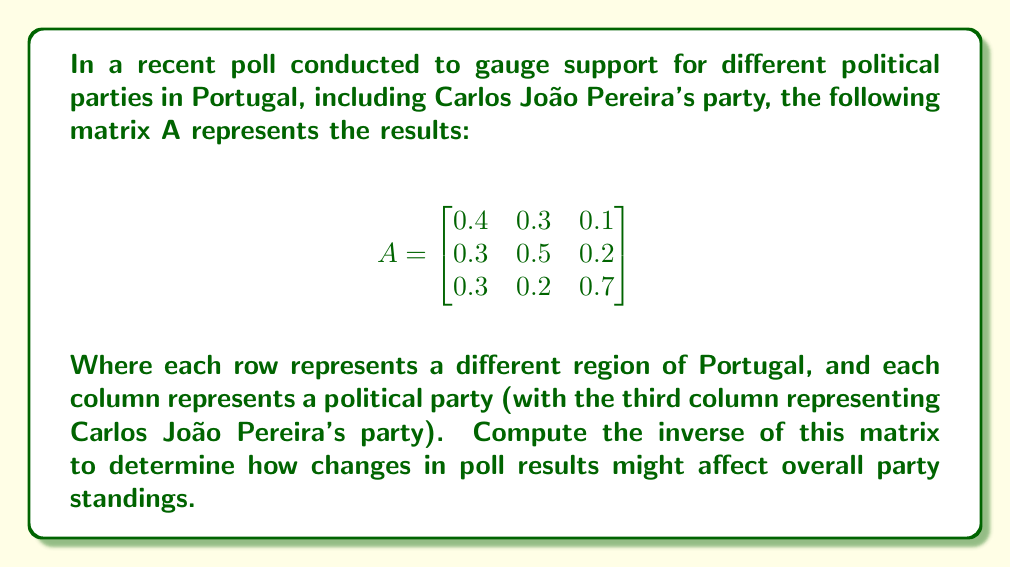Could you help me with this problem? To find the inverse of matrix A, we'll follow these steps:

1) First, we need to calculate the determinant of A:

   $det(A) = 0.4(0.5 \cdot 0.7 - 0.2 \cdot 0.2) - 0.3(0.3 \cdot 0.7 - 0.2 \cdot 0.3) + 0.1(0.3 \cdot 0.2 - 0.5 \cdot 0.3)$
   $= 0.4(0.35 - 0.04) - 0.3(0.21 - 0.06) + 0.1(0.06 - 0.15)$
   $= 0.4(0.31) - 0.3(0.15) + 0.1(-0.09)$
   $= 0.124 - 0.045 - 0.009 = 0.07$

2) Now we calculate the adjugate matrix:

   $adj(A) = \begin{bmatrix}
   (0.5 \cdot 0.7 - 0.2 \cdot 0.2) & -(0.3 \cdot 0.7 - 0.1 \cdot 0.3) & (0.3 \cdot 0.2 - 0.1 \cdot 0.5) \\
   -(0.3 \cdot 0.7 - 0.1 \cdot 0.3) & (0.4 \cdot 0.7 - 0.1 \cdot 0.3) & -(0.4 \cdot 0.2 - 0.1 \cdot 0.3) \\
   (0.3 \cdot 0.5 - 0.2 \cdot 0.3) & -(0.4 \cdot 0.5 - 0.1 \cdot 0.3) & (0.4 \cdot 0.5 - 0.3 \cdot 0.3)
   \end{bmatrix}$

   $= \begin{bmatrix}
   0.31 & -0.18 & 0.01 \\
   -0.18 & 0.25 & -0.05 \\
   0.09 & -0.17 & 0.11
   \end{bmatrix}$

3) Finally, we calculate the inverse using the formula $A^{-1} = \frac{1}{det(A)} \cdot adj(A)$:

   $A^{-1} = \frac{1}{0.07} \cdot \begin{bmatrix}
   0.31 & -0.18 & 0.01 \\
   -0.18 & 0.25 & -0.05 \\
   0.09 & -0.17 & 0.11
   \end{bmatrix}$

   $= \begin{bmatrix}
   4.43 & -2.57 & 0.14 \\
   -2.57 & 3.57 & -0.71 \\
   1.29 & -2.43 & 1.57
   \end{bmatrix}$
Answer: The inverse of matrix A is:

$$A^{-1} = \begin{bmatrix}
4.43 & -2.57 & 0.14 \\
-2.57 & 3.57 & -0.71 \\
1.29 & -2.43 & 1.57
\end{bmatrix}$$ 